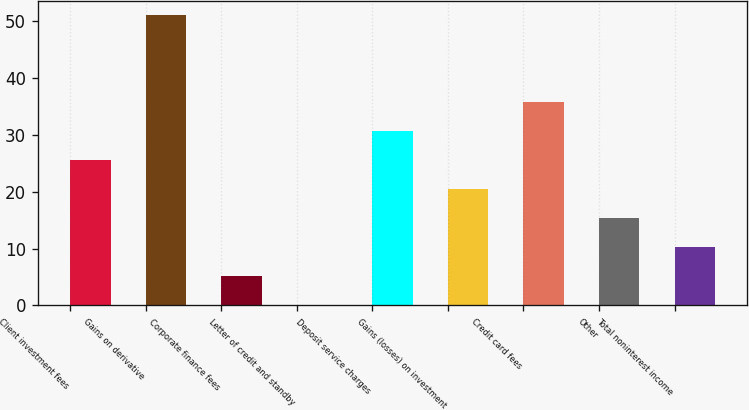Convert chart to OTSL. <chart><loc_0><loc_0><loc_500><loc_500><bar_chart><fcel>Client investment fees<fcel>Gains on derivative<fcel>Corporate finance fees<fcel>Letter of credit and standby<fcel>Deposit service charges<fcel>Gains (losses) on investment<fcel>Credit card fees<fcel>Other<fcel>Total noninterest income<nl><fcel>25.55<fcel>51<fcel>5.19<fcel>0.1<fcel>30.64<fcel>20.46<fcel>35.73<fcel>15.37<fcel>10.28<nl></chart> 